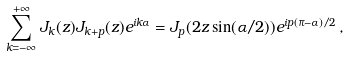<formula> <loc_0><loc_0><loc_500><loc_500>\sum _ { k = - \infty } ^ { + \infty } J _ { k } ( z ) J _ { k + p } ( z ) e ^ { i k \alpha } = J _ { p } ( 2 z \sin ( \alpha / 2 ) ) e ^ { i p ( \pi - \alpha ) / 2 } \, ,</formula> 